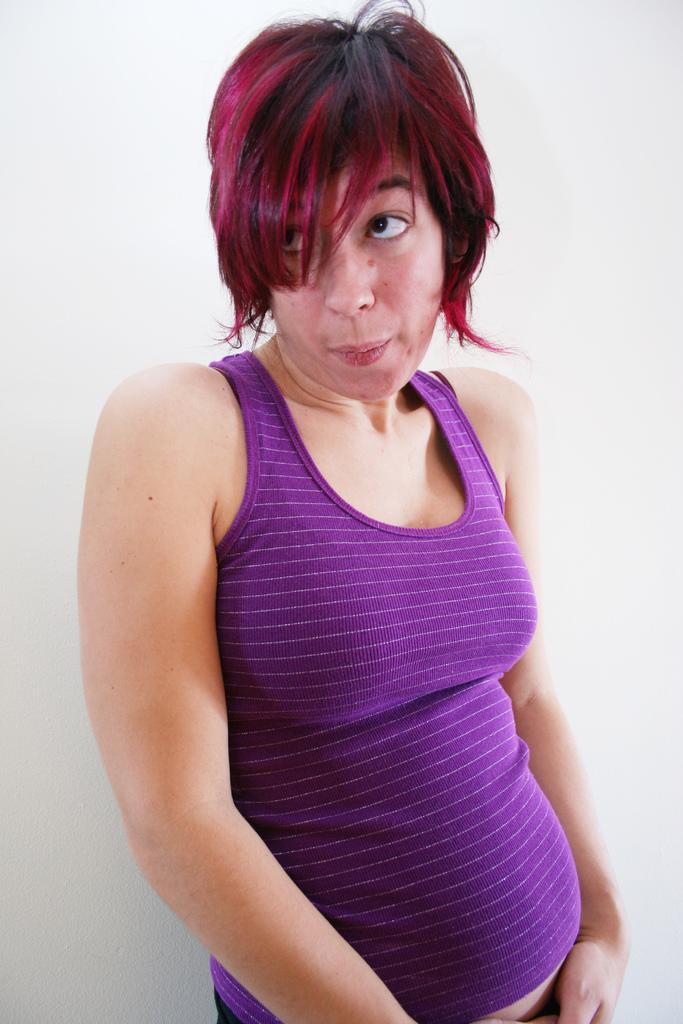Who is present in the image? There is a woman in the image. What is the woman doing in the image? The woman is standing at a wall. What type of furniture can be seen in the image? There is no furniture present in the image. What material is the wall made of in the image? The material of the wall cannot be determined from the image. 